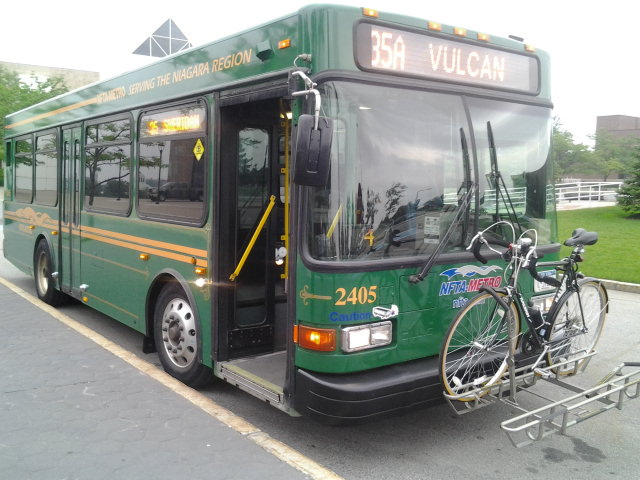Read all the text in this image. VULCAN 35A 2405 REGION NIAGARA 4 METHO NFTA THE SERVING 